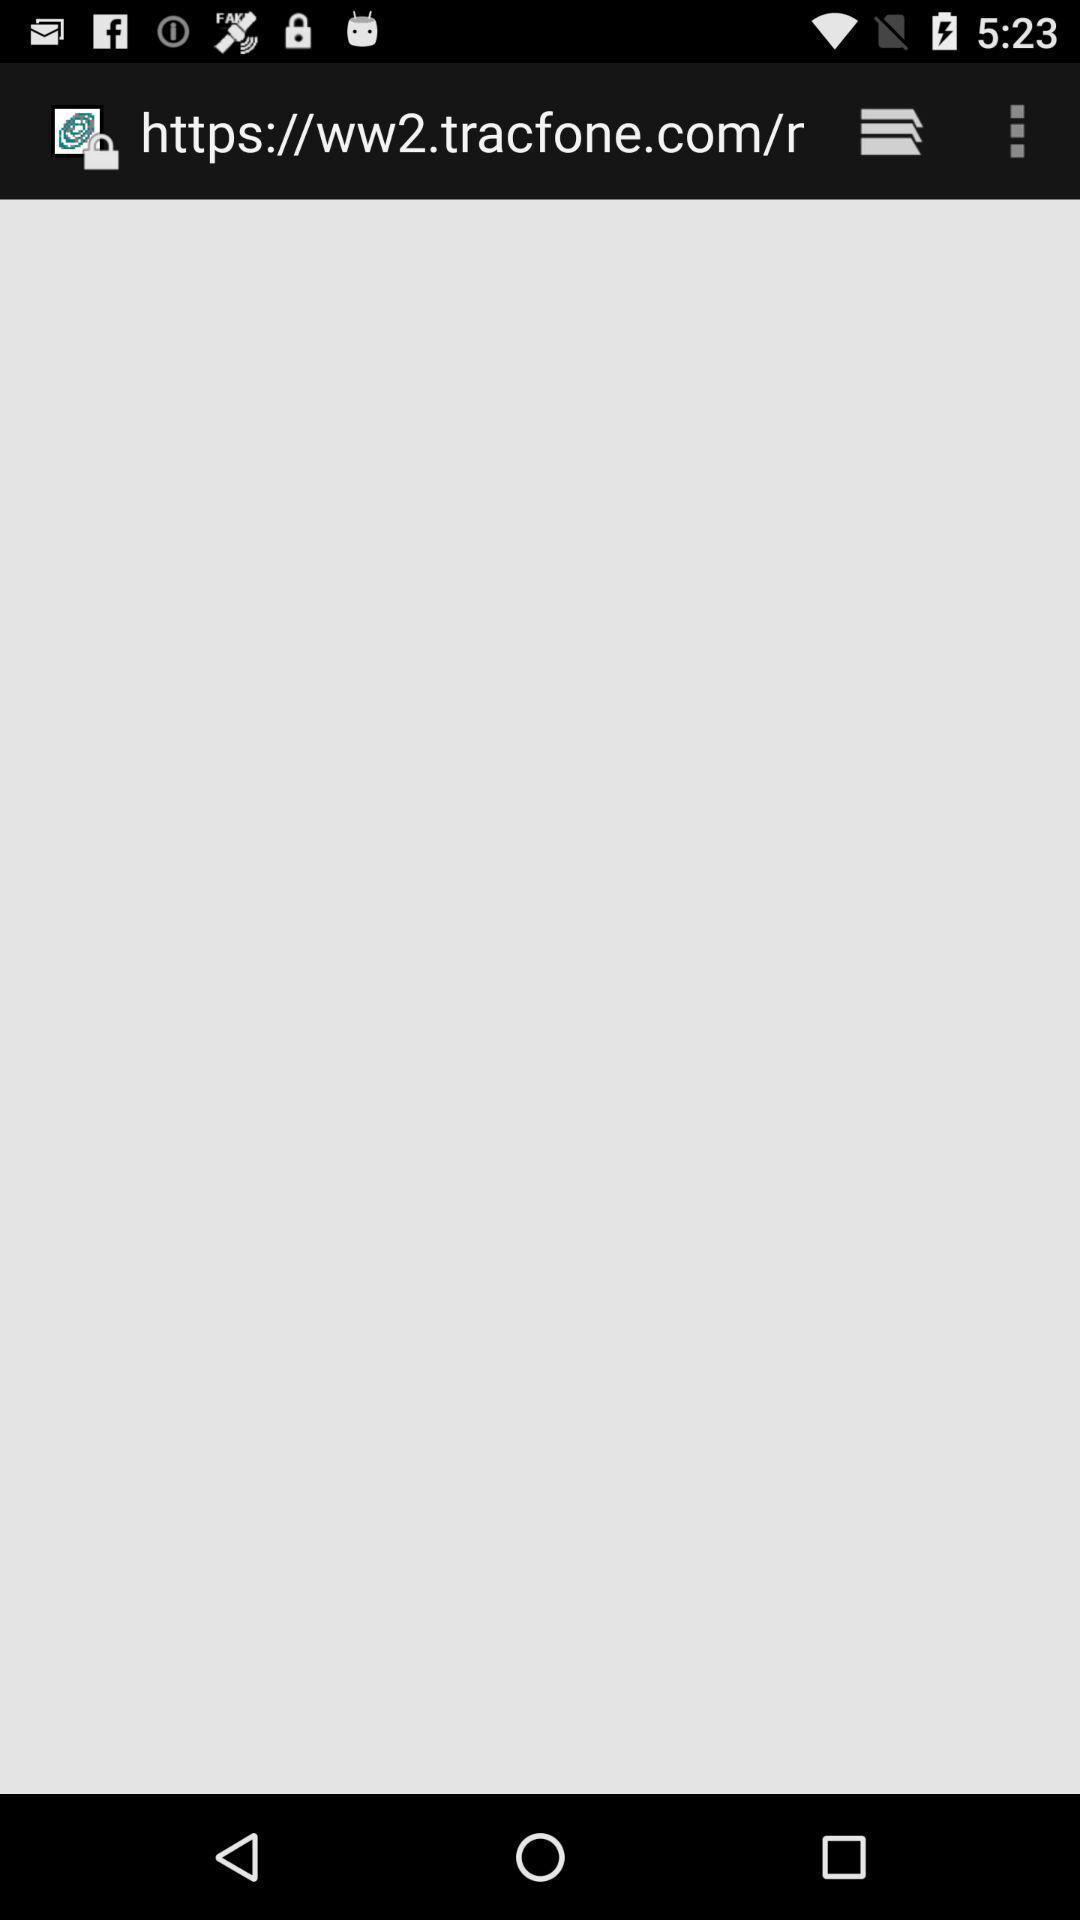Summarize the main components in this picture. Screen shows an url. 